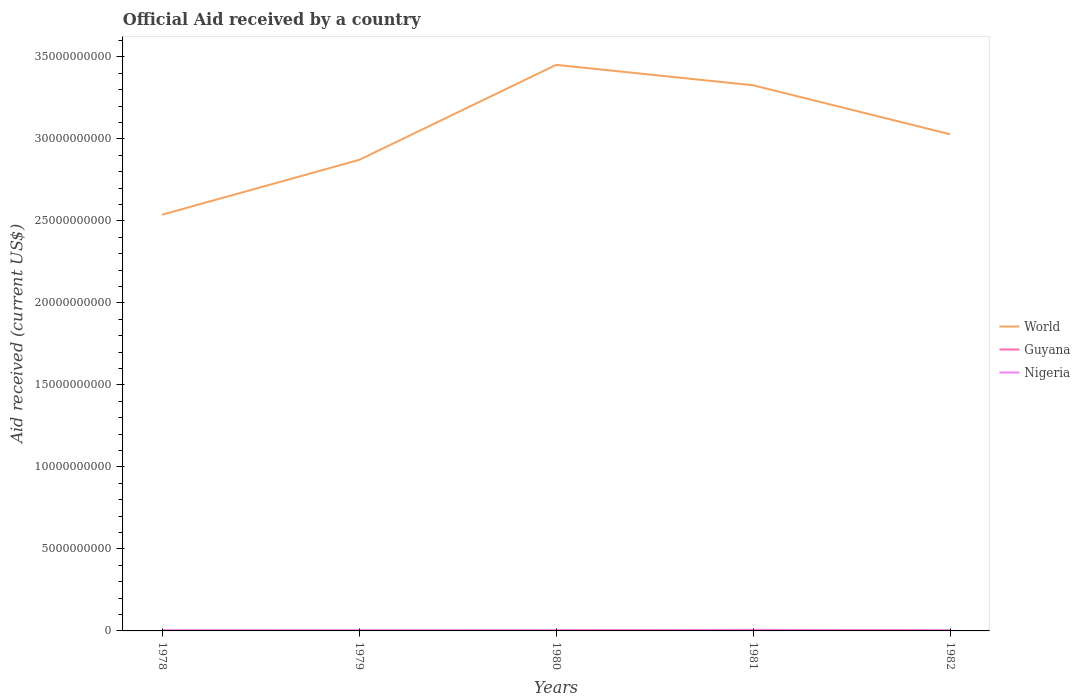Does the line corresponding to World intersect with the line corresponding to Guyana?
Keep it short and to the point. No. Is the number of lines equal to the number of legend labels?
Your response must be concise. Yes. Across all years, what is the maximum net official aid received in Guyana?
Provide a short and direct response. 2.77e+07. In which year was the net official aid received in Guyana maximum?
Keep it short and to the point. 1978. What is the total net official aid received in Guyana in the graph?
Offer a terse response. -4.77e+06. What is the difference between the highest and the second highest net official aid received in Guyana?
Your response must be concise. 3.80e+07. What is the difference between the highest and the lowest net official aid received in World?
Offer a very short reply. 2. Is the net official aid received in Nigeria strictly greater than the net official aid received in Guyana over the years?
Your answer should be compact. No. How many lines are there?
Provide a succinct answer. 3. Are the values on the major ticks of Y-axis written in scientific E-notation?
Keep it short and to the point. No. Does the graph contain any zero values?
Make the answer very short. No. Does the graph contain grids?
Give a very brief answer. No. Where does the legend appear in the graph?
Give a very brief answer. Center right. How many legend labels are there?
Give a very brief answer. 3. What is the title of the graph?
Give a very brief answer. Official Aid received by a country. What is the label or title of the X-axis?
Your answer should be compact. Years. What is the label or title of the Y-axis?
Give a very brief answer. Aid received (current US$). What is the Aid received (current US$) in World in 1978?
Offer a terse response. 2.54e+1. What is the Aid received (current US$) of Guyana in 1978?
Your answer should be very brief. 2.77e+07. What is the Aid received (current US$) of Nigeria in 1978?
Provide a short and direct response. 4.02e+07. What is the Aid received (current US$) in World in 1979?
Keep it short and to the point. 2.87e+1. What is the Aid received (current US$) of Guyana in 1979?
Make the answer very short. 3.42e+07. What is the Aid received (current US$) of Nigeria in 1979?
Your answer should be very brief. 2.57e+07. What is the Aid received (current US$) of World in 1980?
Offer a terse response. 3.45e+1. What is the Aid received (current US$) in Guyana in 1980?
Provide a succinct answer. 4.17e+07. What is the Aid received (current US$) in Nigeria in 1980?
Give a very brief answer. 3.44e+07. What is the Aid received (current US$) of World in 1981?
Your answer should be very brief. 3.33e+1. What is the Aid received (current US$) of Guyana in 1981?
Offer a very short reply. 6.57e+07. What is the Aid received (current US$) in Nigeria in 1981?
Give a very brief answer. 3.92e+07. What is the Aid received (current US$) in World in 1982?
Keep it short and to the point. 3.03e+1. What is the Aid received (current US$) in Guyana in 1982?
Provide a succinct answer. 3.90e+07. What is the Aid received (current US$) in Nigeria in 1982?
Your answer should be compact. 3.50e+07. Across all years, what is the maximum Aid received (current US$) of World?
Keep it short and to the point. 3.45e+1. Across all years, what is the maximum Aid received (current US$) in Guyana?
Give a very brief answer. 6.57e+07. Across all years, what is the maximum Aid received (current US$) in Nigeria?
Provide a succinct answer. 4.02e+07. Across all years, what is the minimum Aid received (current US$) of World?
Ensure brevity in your answer.  2.54e+1. Across all years, what is the minimum Aid received (current US$) of Guyana?
Your response must be concise. 2.77e+07. Across all years, what is the minimum Aid received (current US$) of Nigeria?
Your answer should be compact. 2.57e+07. What is the total Aid received (current US$) of World in the graph?
Offer a terse response. 1.52e+11. What is the total Aid received (current US$) of Guyana in the graph?
Make the answer very short. 2.08e+08. What is the total Aid received (current US$) in Nigeria in the graph?
Give a very brief answer. 1.74e+08. What is the difference between the Aid received (current US$) of World in 1978 and that in 1979?
Your answer should be very brief. -3.34e+09. What is the difference between the Aid received (current US$) in Guyana in 1978 and that in 1979?
Make the answer very short. -6.49e+06. What is the difference between the Aid received (current US$) in Nigeria in 1978 and that in 1979?
Keep it short and to the point. 1.44e+07. What is the difference between the Aid received (current US$) of World in 1978 and that in 1980?
Your answer should be very brief. -9.13e+09. What is the difference between the Aid received (current US$) of Guyana in 1978 and that in 1980?
Your response must be concise. -1.40e+07. What is the difference between the Aid received (current US$) in Nigeria in 1978 and that in 1980?
Your answer should be very brief. 5.75e+06. What is the difference between the Aid received (current US$) of World in 1978 and that in 1981?
Keep it short and to the point. -7.89e+09. What is the difference between the Aid received (current US$) of Guyana in 1978 and that in 1981?
Your response must be concise. -3.80e+07. What is the difference between the Aid received (current US$) of World in 1978 and that in 1982?
Offer a very short reply. -4.90e+09. What is the difference between the Aid received (current US$) in Guyana in 1978 and that in 1982?
Your answer should be compact. -1.13e+07. What is the difference between the Aid received (current US$) of Nigeria in 1978 and that in 1982?
Your response must be concise. 5.20e+06. What is the difference between the Aid received (current US$) in World in 1979 and that in 1980?
Offer a terse response. -5.79e+09. What is the difference between the Aid received (current US$) of Guyana in 1979 and that in 1980?
Provide a succinct answer. -7.53e+06. What is the difference between the Aid received (current US$) in Nigeria in 1979 and that in 1980?
Offer a terse response. -8.66e+06. What is the difference between the Aid received (current US$) in World in 1979 and that in 1981?
Offer a terse response. -4.55e+09. What is the difference between the Aid received (current US$) of Guyana in 1979 and that in 1981?
Offer a terse response. -3.15e+07. What is the difference between the Aid received (current US$) of Nigeria in 1979 and that in 1981?
Offer a terse response. -1.35e+07. What is the difference between the Aid received (current US$) in World in 1979 and that in 1982?
Offer a terse response. -1.56e+09. What is the difference between the Aid received (current US$) of Guyana in 1979 and that in 1982?
Your answer should be compact. -4.77e+06. What is the difference between the Aid received (current US$) of Nigeria in 1979 and that in 1982?
Offer a very short reply. -9.21e+06. What is the difference between the Aid received (current US$) of World in 1980 and that in 1981?
Offer a terse response. 1.24e+09. What is the difference between the Aid received (current US$) in Guyana in 1980 and that in 1981?
Your answer should be compact. -2.40e+07. What is the difference between the Aid received (current US$) in Nigeria in 1980 and that in 1981?
Provide a succinct answer. -4.85e+06. What is the difference between the Aid received (current US$) of World in 1980 and that in 1982?
Your response must be concise. 4.23e+09. What is the difference between the Aid received (current US$) in Guyana in 1980 and that in 1982?
Offer a very short reply. 2.76e+06. What is the difference between the Aid received (current US$) in Nigeria in 1980 and that in 1982?
Make the answer very short. -5.50e+05. What is the difference between the Aid received (current US$) in World in 1981 and that in 1982?
Ensure brevity in your answer.  2.99e+09. What is the difference between the Aid received (current US$) in Guyana in 1981 and that in 1982?
Your answer should be very brief. 2.67e+07. What is the difference between the Aid received (current US$) in Nigeria in 1981 and that in 1982?
Your answer should be very brief. 4.30e+06. What is the difference between the Aid received (current US$) in World in 1978 and the Aid received (current US$) in Guyana in 1979?
Ensure brevity in your answer.  2.53e+1. What is the difference between the Aid received (current US$) in World in 1978 and the Aid received (current US$) in Nigeria in 1979?
Ensure brevity in your answer.  2.54e+1. What is the difference between the Aid received (current US$) of Guyana in 1978 and the Aid received (current US$) of Nigeria in 1979?
Your answer should be very brief. 1.97e+06. What is the difference between the Aid received (current US$) in World in 1978 and the Aid received (current US$) in Guyana in 1980?
Provide a short and direct response. 2.53e+1. What is the difference between the Aid received (current US$) in World in 1978 and the Aid received (current US$) in Nigeria in 1980?
Your response must be concise. 2.53e+1. What is the difference between the Aid received (current US$) of Guyana in 1978 and the Aid received (current US$) of Nigeria in 1980?
Make the answer very short. -6.69e+06. What is the difference between the Aid received (current US$) in World in 1978 and the Aid received (current US$) in Guyana in 1981?
Provide a succinct answer. 2.53e+1. What is the difference between the Aid received (current US$) in World in 1978 and the Aid received (current US$) in Nigeria in 1981?
Offer a very short reply. 2.53e+1. What is the difference between the Aid received (current US$) of Guyana in 1978 and the Aid received (current US$) of Nigeria in 1981?
Your response must be concise. -1.15e+07. What is the difference between the Aid received (current US$) of World in 1978 and the Aid received (current US$) of Guyana in 1982?
Ensure brevity in your answer.  2.53e+1. What is the difference between the Aid received (current US$) in World in 1978 and the Aid received (current US$) in Nigeria in 1982?
Make the answer very short. 2.53e+1. What is the difference between the Aid received (current US$) of Guyana in 1978 and the Aid received (current US$) of Nigeria in 1982?
Keep it short and to the point. -7.24e+06. What is the difference between the Aid received (current US$) of World in 1979 and the Aid received (current US$) of Guyana in 1980?
Give a very brief answer. 2.87e+1. What is the difference between the Aid received (current US$) in World in 1979 and the Aid received (current US$) in Nigeria in 1980?
Give a very brief answer. 2.87e+1. What is the difference between the Aid received (current US$) in World in 1979 and the Aid received (current US$) in Guyana in 1981?
Offer a very short reply. 2.87e+1. What is the difference between the Aid received (current US$) in World in 1979 and the Aid received (current US$) in Nigeria in 1981?
Keep it short and to the point. 2.87e+1. What is the difference between the Aid received (current US$) in Guyana in 1979 and the Aid received (current US$) in Nigeria in 1981?
Your response must be concise. -5.05e+06. What is the difference between the Aid received (current US$) in World in 1979 and the Aid received (current US$) in Guyana in 1982?
Keep it short and to the point. 2.87e+1. What is the difference between the Aid received (current US$) in World in 1979 and the Aid received (current US$) in Nigeria in 1982?
Offer a terse response. 2.87e+1. What is the difference between the Aid received (current US$) in Guyana in 1979 and the Aid received (current US$) in Nigeria in 1982?
Provide a succinct answer. -7.50e+05. What is the difference between the Aid received (current US$) in World in 1980 and the Aid received (current US$) in Guyana in 1981?
Offer a terse response. 3.44e+1. What is the difference between the Aid received (current US$) in World in 1980 and the Aid received (current US$) in Nigeria in 1981?
Provide a succinct answer. 3.45e+1. What is the difference between the Aid received (current US$) of Guyana in 1980 and the Aid received (current US$) of Nigeria in 1981?
Offer a terse response. 2.48e+06. What is the difference between the Aid received (current US$) in World in 1980 and the Aid received (current US$) in Guyana in 1982?
Offer a very short reply. 3.45e+1. What is the difference between the Aid received (current US$) of World in 1980 and the Aid received (current US$) of Nigeria in 1982?
Offer a terse response. 3.45e+1. What is the difference between the Aid received (current US$) of Guyana in 1980 and the Aid received (current US$) of Nigeria in 1982?
Make the answer very short. 6.78e+06. What is the difference between the Aid received (current US$) in World in 1981 and the Aid received (current US$) in Guyana in 1982?
Offer a very short reply. 3.32e+1. What is the difference between the Aid received (current US$) of World in 1981 and the Aid received (current US$) of Nigeria in 1982?
Make the answer very short. 3.32e+1. What is the difference between the Aid received (current US$) of Guyana in 1981 and the Aid received (current US$) of Nigeria in 1982?
Make the answer very short. 3.08e+07. What is the average Aid received (current US$) in World per year?
Ensure brevity in your answer.  3.04e+1. What is the average Aid received (current US$) in Guyana per year?
Your answer should be compact. 4.17e+07. What is the average Aid received (current US$) in Nigeria per year?
Your answer should be very brief. 3.49e+07. In the year 1978, what is the difference between the Aid received (current US$) of World and Aid received (current US$) of Guyana?
Provide a short and direct response. 2.54e+1. In the year 1978, what is the difference between the Aid received (current US$) of World and Aid received (current US$) of Nigeria?
Ensure brevity in your answer.  2.53e+1. In the year 1978, what is the difference between the Aid received (current US$) of Guyana and Aid received (current US$) of Nigeria?
Offer a terse response. -1.24e+07. In the year 1979, what is the difference between the Aid received (current US$) of World and Aid received (current US$) of Guyana?
Your answer should be compact. 2.87e+1. In the year 1979, what is the difference between the Aid received (current US$) in World and Aid received (current US$) in Nigeria?
Your answer should be very brief. 2.87e+1. In the year 1979, what is the difference between the Aid received (current US$) of Guyana and Aid received (current US$) of Nigeria?
Your answer should be very brief. 8.46e+06. In the year 1980, what is the difference between the Aid received (current US$) in World and Aid received (current US$) in Guyana?
Your response must be concise. 3.45e+1. In the year 1980, what is the difference between the Aid received (current US$) of World and Aid received (current US$) of Nigeria?
Provide a succinct answer. 3.45e+1. In the year 1980, what is the difference between the Aid received (current US$) of Guyana and Aid received (current US$) of Nigeria?
Offer a terse response. 7.33e+06. In the year 1981, what is the difference between the Aid received (current US$) in World and Aid received (current US$) in Guyana?
Offer a terse response. 3.32e+1. In the year 1981, what is the difference between the Aid received (current US$) in World and Aid received (current US$) in Nigeria?
Provide a short and direct response. 3.32e+1. In the year 1981, what is the difference between the Aid received (current US$) of Guyana and Aid received (current US$) of Nigeria?
Offer a terse response. 2.64e+07. In the year 1982, what is the difference between the Aid received (current US$) of World and Aid received (current US$) of Guyana?
Offer a terse response. 3.02e+1. In the year 1982, what is the difference between the Aid received (current US$) of World and Aid received (current US$) of Nigeria?
Your answer should be very brief. 3.02e+1. In the year 1982, what is the difference between the Aid received (current US$) of Guyana and Aid received (current US$) of Nigeria?
Give a very brief answer. 4.02e+06. What is the ratio of the Aid received (current US$) in World in 1978 to that in 1979?
Your response must be concise. 0.88. What is the ratio of the Aid received (current US$) of Guyana in 1978 to that in 1979?
Offer a very short reply. 0.81. What is the ratio of the Aid received (current US$) in Nigeria in 1978 to that in 1979?
Provide a succinct answer. 1.56. What is the ratio of the Aid received (current US$) in World in 1978 to that in 1980?
Give a very brief answer. 0.74. What is the ratio of the Aid received (current US$) in Guyana in 1978 to that in 1980?
Ensure brevity in your answer.  0.66. What is the ratio of the Aid received (current US$) of Nigeria in 1978 to that in 1980?
Give a very brief answer. 1.17. What is the ratio of the Aid received (current US$) of World in 1978 to that in 1981?
Give a very brief answer. 0.76. What is the ratio of the Aid received (current US$) in Guyana in 1978 to that in 1981?
Ensure brevity in your answer.  0.42. What is the ratio of the Aid received (current US$) in Nigeria in 1978 to that in 1981?
Offer a very short reply. 1.02. What is the ratio of the Aid received (current US$) of World in 1978 to that in 1982?
Give a very brief answer. 0.84. What is the ratio of the Aid received (current US$) in Guyana in 1978 to that in 1982?
Keep it short and to the point. 0.71. What is the ratio of the Aid received (current US$) in Nigeria in 1978 to that in 1982?
Offer a very short reply. 1.15. What is the ratio of the Aid received (current US$) of World in 1979 to that in 1980?
Your response must be concise. 0.83. What is the ratio of the Aid received (current US$) of Guyana in 1979 to that in 1980?
Your response must be concise. 0.82. What is the ratio of the Aid received (current US$) of Nigeria in 1979 to that in 1980?
Your answer should be compact. 0.75. What is the ratio of the Aid received (current US$) in World in 1979 to that in 1981?
Offer a terse response. 0.86. What is the ratio of the Aid received (current US$) of Guyana in 1979 to that in 1981?
Your answer should be compact. 0.52. What is the ratio of the Aid received (current US$) of Nigeria in 1979 to that in 1981?
Keep it short and to the point. 0.66. What is the ratio of the Aid received (current US$) of World in 1979 to that in 1982?
Offer a very short reply. 0.95. What is the ratio of the Aid received (current US$) in Guyana in 1979 to that in 1982?
Give a very brief answer. 0.88. What is the ratio of the Aid received (current US$) of Nigeria in 1979 to that in 1982?
Offer a very short reply. 0.74. What is the ratio of the Aid received (current US$) of World in 1980 to that in 1981?
Provide a succinct answer. 1.04. What is the ratio of the Aid received (current US$) in Guyana in 1980 to that in 1981?
Your answer should be very brief. 0.64. What is the ratio of the Aid received (current US$) of Nigeria in 1980 to that in 1981?
Give a very brief answer. 0.88. What is the ratio of the Aid received (current US$) of World in 1980 to that in 1982?
Provide a succinct answer. 1.14. What is the ratio of the Aid received (current US$) of Guyana in 1980 to that in 1982?
Provide a short and direct response. 1.07. What is the ratio of the Aid received (current US$) in Nigeria in 1980 to that in 1982?
Provide a succinct answer. 0.98. What is the ratio of the Aid received (current US$) in World in 1981 to that in 1982?
Offer a terse response. 1.1. What is the ratio of the Aid received (current US$) in Guyana in 1981 to that in 1982?
Make the answer very short. 1.69. What is the ratio of the Aid received (current US$) of Nigeria in 1981 to that in 1982?
Give a very brief answer. 1.12. What is the difference between the highest and the second highest Aid received (current US$) of World?
Give a very brief answer. 1.24e+09. What is the difference between the highest and the second highest Aid received (current US$) of Guyana?
Ensure brevity in your answer.  2.40e+07. What is the difference between the highest and the lowest Aid received (current US$) of World?
Ensure brevity in your answer.  9.13e+09. What is the difference between the highest and the lowest Aid received (current US$) in Guyana?
Give a very brief answer. 3.80e+07. What is the difference between the highest and the lowest Aid received (current US$) in Nigeria?
Ensure brevity in your answer.  1.44e+07. 